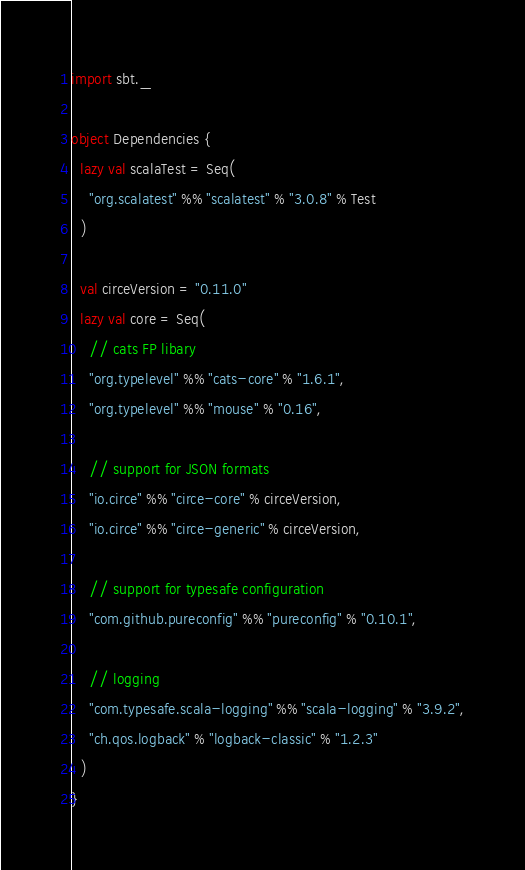<code> <loc_0><loc_0><loc_500><loc_500><_Scala_>import sbt._

object Dependencies {
  lazy val scalaTest = Seq(
    "org.scalatest" %% "scalatest" % "3.0.8" % Test
  )

  val circeVersion = "0.11.0"
  lazy val core = Seq(
    // cats FP libary
    "org.typelevel" %% "cats-core" % "1.6.1",
    "org.typelevel" %% "mouse" % "0.16",

    // support for JSON formats
    "io.circe" %% "circe-core" % circeVersion,
    "io.circe" %% "circe-generic" % circeVersion,

    // support for typesafe configuration
    "com.github.pureconfig" %% "pureconfig" % "0.10.1",

    // logging
    "com.typesafe.scala-logging" %% "scala-logging" % "3.9.2",
    "ch.qos.logback" % "logback-classic" % "1.2.3"
  )
}
</code> 